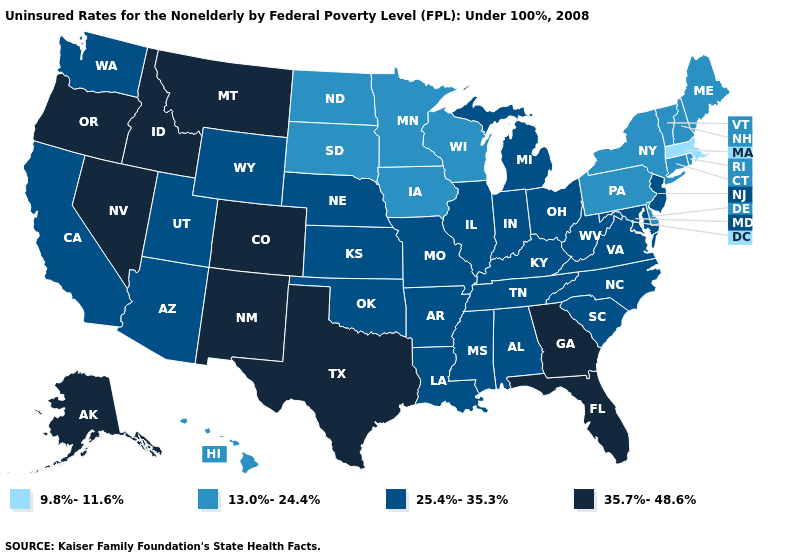What is the lowest value in the USA?
Short answer required. 9.8%-11.6%. Does Georgia have the same value as Colorado?
Concise answer only. Yes. What is the value of Illinois?
Answer briefly. 25.4%-35.3%. Does Alaska have the same value as Montana?
Keep it brief. Yes. Name the states that have a value in the range 25.4%-35.3%?
Answer briefly. Alabama, Arizona, Arkansas, California, Illinois, Indiana, Kansas, Kentucky, Louisiana, Maryland, Michigan, Mississippi, Missouri, Nebraska, New Jersey, North Carolina, Ohio, Oklahoma, South Carolina, Tennessee, Utah, Virginia, Washington, West Virginia, Wyoming. What is the lowest value in the West?
Answer briefly. 13.0%-24.4%. What is the value of Wisconsin?
Quick response, please. 13.0%-24.4%. Does Florida have a higher value than Nevada?
Quick response, please. No. What is the lowest value in the USA?
Answer briefly. 9.8%-11.6%. Name the states that have a value in the range 25.4%-35.3%?
Concise answer only. Alabama, Arizona, Arkansas, California, Illinois, Indiana, Kansas, Kentucky, Louisiana, Maryland, Michigan, Mississippi, Missouri, Nebraska, New Jersey, North Carolina, Ohio, Oklahoma, South Carolina, Tennessee, Utah, Virginia, Washington, West Virginia, Wyoming. Does Massachusetts have the highest value in the USA?
Be succinct. No. What is the value of Louisiana?
Answer briefly. 25.4%-35.3%. What is the lowest value in states that border New Jersey?
Keep it brief. 13.0%-24.4%. Name the states that have a value in the range 13.0%-24.4%?
Keep it brief. Connecticut, Delaware, Hawaii, Iowa, Maine, Minnesota, New Hampshire, New York, North Dakota, Pennsylvania, Rhode Island, South Dakota, Vermont, Wisconsin. 